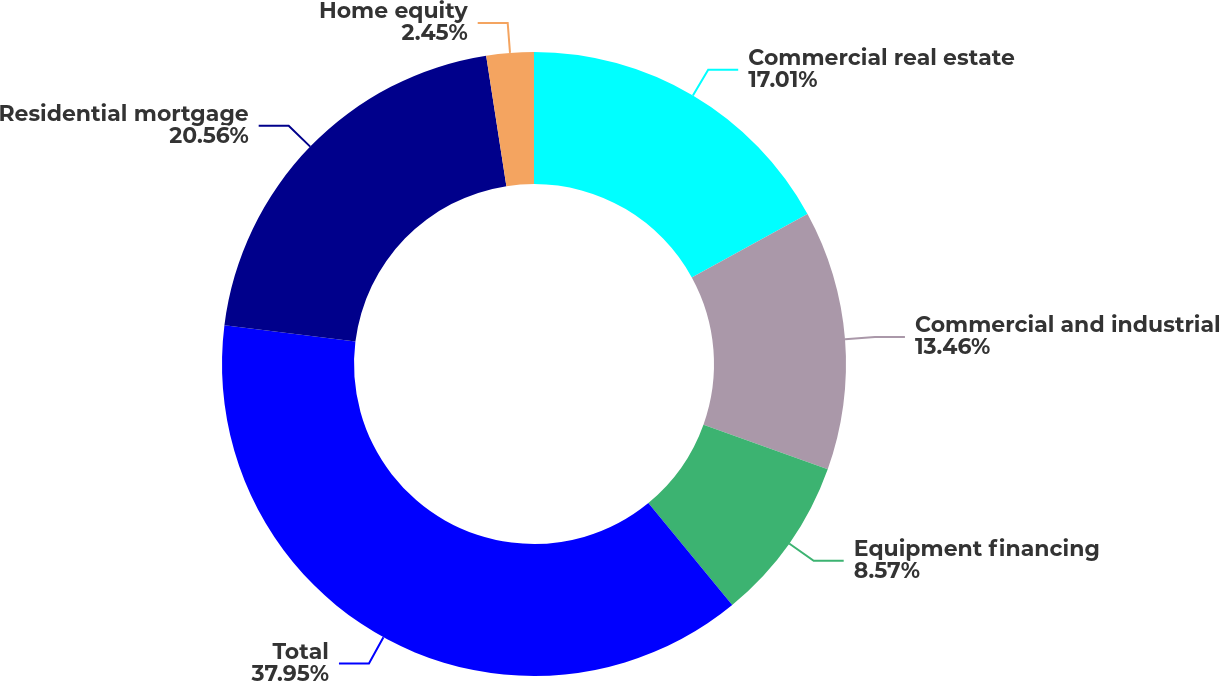<chart> <loc_0><loc_0><loc_500><loc_500><pie_chart><fcel>Commercial real estate<fcel>Commercial and industrial<fcel>Equipment financing<fcel>Total<fcel>Residential mortgage<fcel>Home equity<nl><fcel>17.01%<fcel>13.46%<fcel>8.57%<fcel>37.94%<fcel>20.56%<fcel>2.45%<nl></chart> 